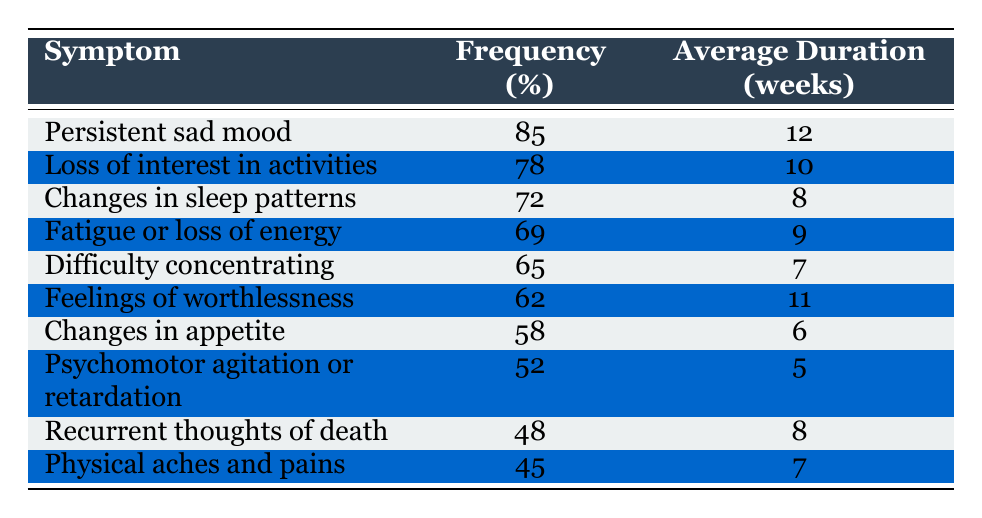What is the most frequently reported symptom of depression? The table lists the symptoms in order of frequency, with "Persistent sad mood" at the top, indicating it is the most frequently reported symptom at 85%.
Answer: 85% How many weeks is the average duration for the symptom "Fatigue or loss of energy"? Looking at the table, the average duration specifically for "Fatigue or loss of energy" is 9 weeks, as shown in the corresponding row.
Answer: 9 weeks Is "Changes in appetite" reported by more than 50% of individuals with depression? By checking the frequency for "Changes in appetite," which is listed at 58%, we can see that it is indeed more than 50%.
Answer: Yes What is the difference in frequency between "Recurrent thoughts of death" and "Psychomotor agitation or retardation"? "Recurrent thoughts of death" has a frequency of 48%, while "Psychomotor agitation or retardation" has a frequency of 52%. The difference is calculated as 52% - 48% = 4%.
Answer: 4% How many symptoms have an average duration of 8 weeks or more? We can see from the table that the symptoms with durations of 8 weeks or more are "Persistent sad mood" (12 weeks), "Loss of interest in activities" (10 weeks), "Changes in sleep patterns" (8 weeks), "Feelings of worthlessness" (11 weeks), and "Recurrent thoughts of death" (8 weeks). This gives us a total of 5 symptoms.
Answer: 5 Which symptom has the lowest frequency of occurrence? Among all listed symptoms, the lowest frequency is for "Physical aches and pains," which is at 45%.
Answer: 45% What is the average duration of the top three most frequently reported symptoms? The top three symptoms are "Persistent sad mood" (12 weeks), "Loss of interest in activities" (10 weeks), and "Changes in sleep patterns" (8 weeks). To find the average duration, we sum these durations: 12 + 10 + 8 = 30, and divide by 3. So, the average duration is 30/3 = 10 weeks.
Answer: 10 weeks Is the frequency of "Feelings of worthlessness" higher than "Changes in sleep patterns"? "Feelings of worthlessness" has a frequency of 62%, while "Changes in sleep patterns" has a frequency of 72%. Since 62% is not higher than 72%, the statement is false.
Answer: No What is the total frequency percentage of the symptoms listed? We sum up the frequency percentages of all symptoms: 85 + 78 + 72 + 69 + 65 + 62 + 58 + 52 + 48 + 45 = 759%. This gives a total frequency percentage of 759%.
Answer: 759% 